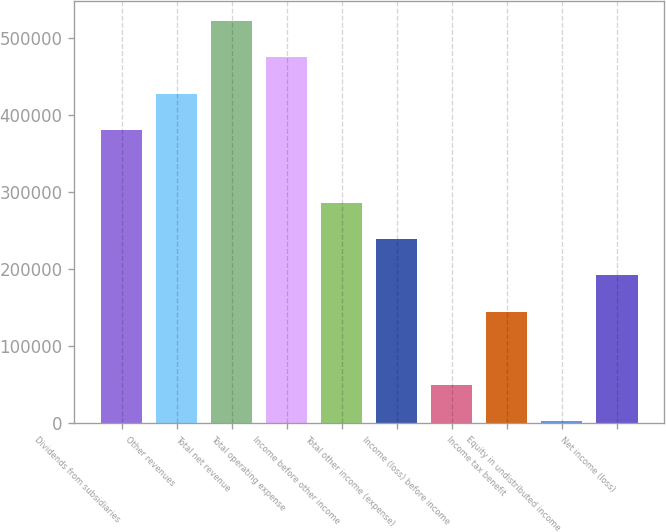<chart> <loc_0><loc_0><loc_500><loc_500><bar_chart><fcel>Dividends from subsidiaries<fcel>Other revenues<fcel>Total net revenue<fcel>Total operating expense<fcel>Income before other income<fcel>Total other income (expense)<fcel>Income (loss) before income<fcel>Income tax benefit<fcel>Equity in undistributed income<fcel>Net income (loss)<nl><fcel>380052<fcel>427147<fcel>521337<fcel>474242<fcel>285862<fcel>238768<fcel>50387.9<fcel>144578<fcel>3293<fcel>191673<nl></chart> 